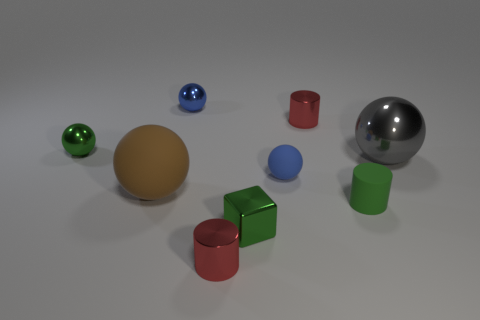Add 1 green rubber things. How many objects exist? 10 How many red cylinders must be subtracted to get 1 red cylinders? 1 Subtract 1 blocks. How many blocks are left? 0 Subtract all brown cubes. Subtract all brown balls. How many cubes are left? 1 Subtract all red spheres. How many brown cylinders are left? 0 Subtract all big brown metallic things. Subtract all large matte balls. How many objects are left? 8 Add 2 metallic things. How many metallic things are left? 8 Add 2 small metal spheres. How many small metal spheres exist? 4 Subtract all green spheres. How many spheres are left? 4 Subtract all big brown matte spheres. How many spheres are left? 4 